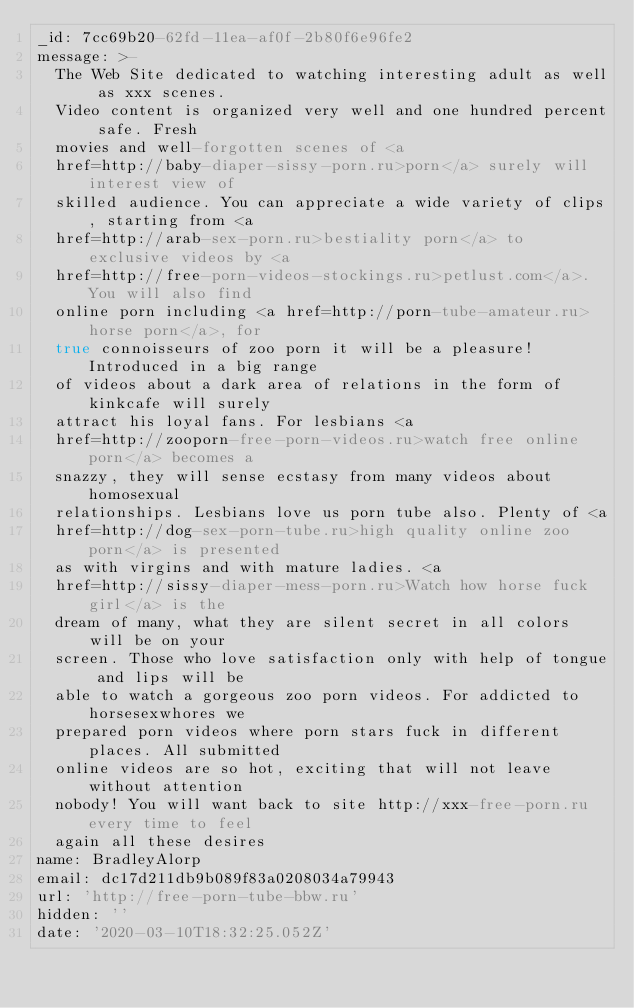Convert code to text. <code><loc_0><loc_0><loc_500><loc_500><_YAML_>_id: 7cc69b20-62fd-11ea-af0f-2b80f6e96fe2
message: >-
  The Web Site dedicated to watching interesting adult as well as xxx scenes.
  Video content is organized very well and one hundred percent safe. Fresh
  movies and well-forgotten scenes of <a
  href=http://baby-diaper-sissy-porn.ru>porn</a> surely will interest view of
  skilled audience. You can appreciate a wide variety of clips, starting from <a
  href=http://arab-sex-porn.ru>bestiality porn</a> to exclusive videos by <a
  href=http://free-porn-videos-stockings.ru>petlust.com</a>. You will also find
  online porn including <a href=http://porn-tube-amateur.ru>horse porn</a>, for
  true connoisseurs of zoo porn it will be a pleasure! Introduced in a big range
  of videos about a dark area of relations in the form of kinkcafe will surely
  attract his loyal fans. For lesbians <a
  href=http://zooporn-free-porn-videos.ru>watch free online porn</a> becomes a
  snazzy, they will sense ecstasy from many videos about homosexual
  relationships. Lesbians love us porn tube also. Plenty of <a
  href=http://dog-sex-porn-tube.ru>high quality online zoo porn</a> is presented
  as with virgins and with mature ladies. <a
  href=http://sissy-diaper-mess-porn.ru>Watch how horse fuck girl</a> is the
  dream of many, what they are silent secret in all colors will be on your
  screen. Those who love satisfaction only with help of tongue and lips will be
  able to watch a gorgeous zoo porn videos. For addicted to horsesexwhores we
  prepared porn videos where porn stars fuck in different places. All submitted
  online videos are so hot, exciting that will not leave without attention
  nobody! You will want back to site http://xxx-free-porn.ru every time to feel
  again all these desires
name: BradleyAlorp
email: dc17d211db9b089f83a0208034a79943
url: 'http://free-porn-tube-bbw.ru'
hidden: ''
date: '2020-03-10T18:32:25.052Z'
</code> 